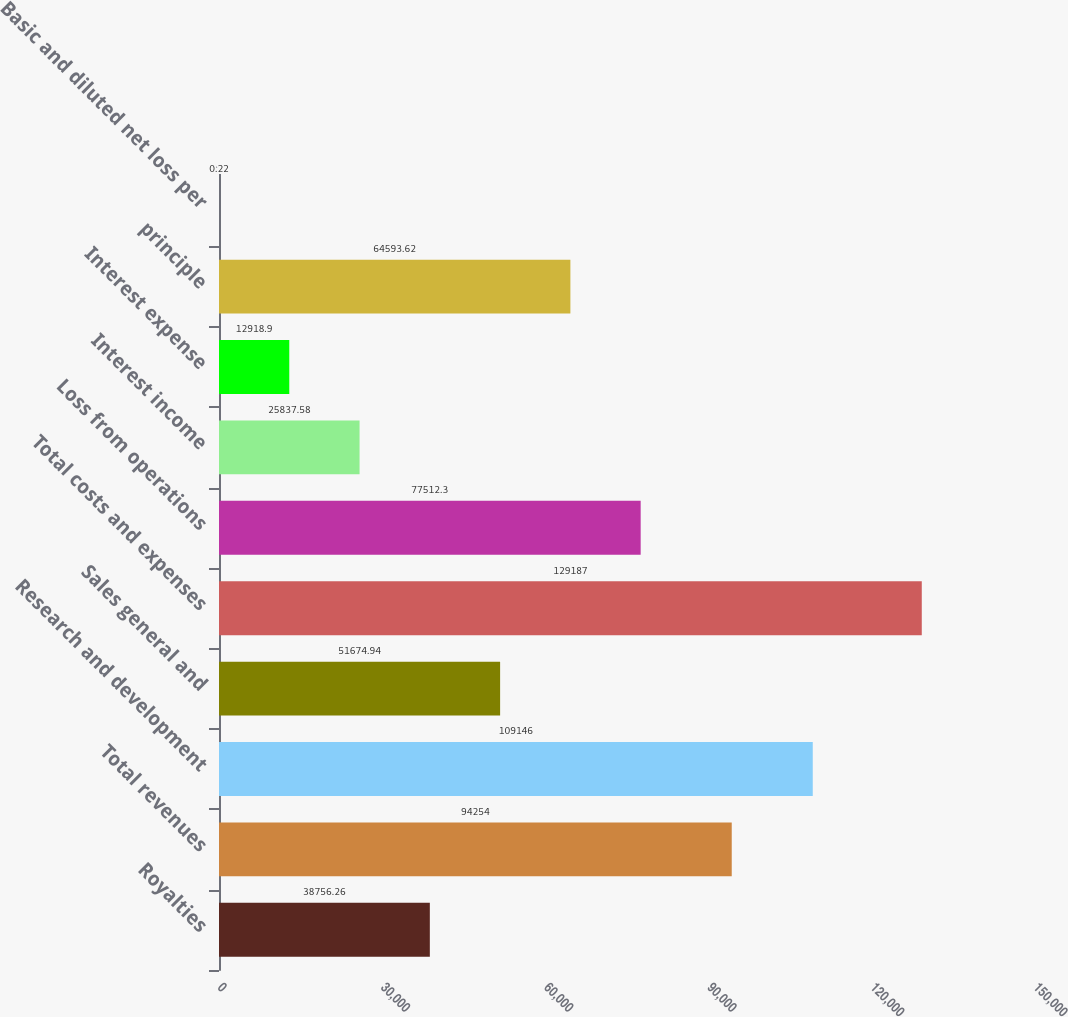<chart> <loc_0><loc_0><loc_500><loc_500><bar_chart><fcel>Royalties<fcel>Total revenues<fcel>Research and development<fcel>Sales general and<fcel>Total costs and expenses<fcel>Loss from operations<fcel>Interest income<fcel>Interest expense<fcel>principle<fcel>Basic and diluted net loss per<nl><fcel>38756.3<fcel>94254<fcel>109146<fcel>51674.9<fcel>129187<fcel>77512.3<fcel>25837.6<fcel>12918.9<fcel>64593.6<fcel>0.22<nl></chart> 